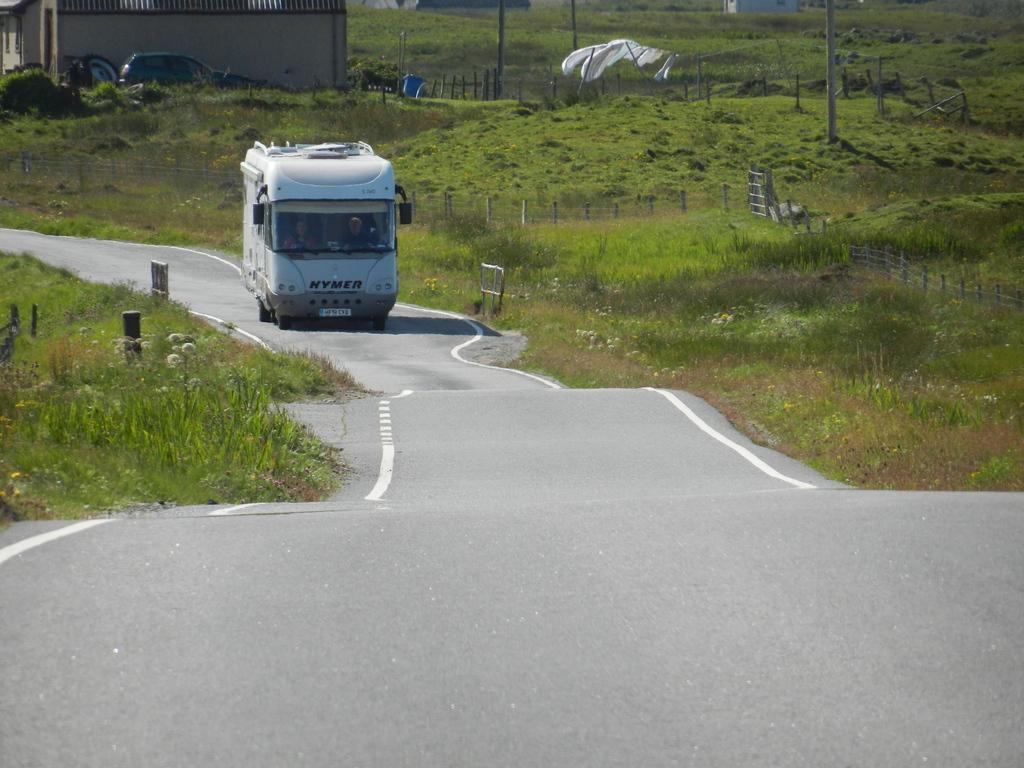Can you describe this image briefly? This is an outside view. In this image I can see a bus on the road. On both sides of the road, I can see the grass and plants. In the top left there is a house and a car. On the right side there are few poles and a fencing. 